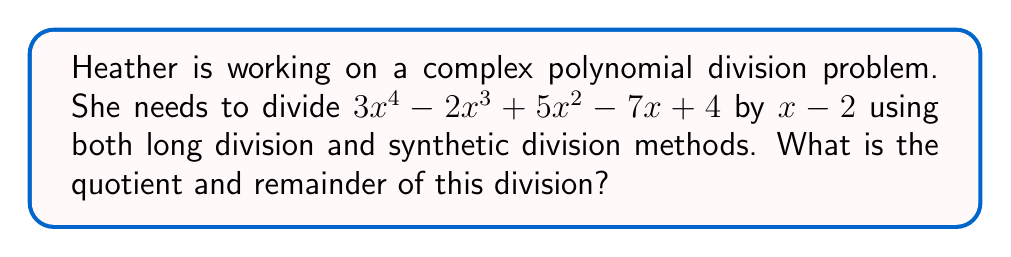Show me your answer to this math problem. Let's solve this problem using both long division and synthetic division:

1. Long Division Method:

$$\begin{array}{r}
3x^3 + 4x^2 + 13x + 19 \\
x - 2 \enclose{longdiv}{3x^4 - 2x^3 + 5x^2 - 7x + 4} \\
\underline{3x^4 - 6x^3} \\
4x^3 + 5x^2 \\
\underline{4x^3 - 8x^2} \\
13x^2 - 7x \\
\underline{13x^2 - 26x} \\
19x + 4 \\
\underline{19x - 38} \\
42
\end{array}$$

2. Synthetic Division Method:

$$\begin{array}{r|rrrr}
2 & 3 & -2 & 5 & -7 & 4 \\
\hline
  & 6 & 8 & 26 & 38 \\
\hline
  & 3 & 4 & 13 & 19 & 42
\end{array}$$

Both methods yield the same result:

Quotient: $3x^3 + 4x^2 + 13x + 19$
Remainder: $42$

The synthetic division method is more concise and less prone to errors, especially for higher degree polynomials. However, the long division method provides a clear step-by-step process that can be useful for understanding the division process.
Answer: Quotient: $3x^3 + 4x^2 + 13x + 19$, Remainder: $42$ 